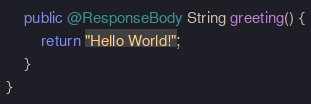Convert code to text. <code><loc_0><loc_0><loc_500><loc_500><_Java_>    public @ResponseBody String greeting() {
        return "Hello World!";
    }
}</code> 